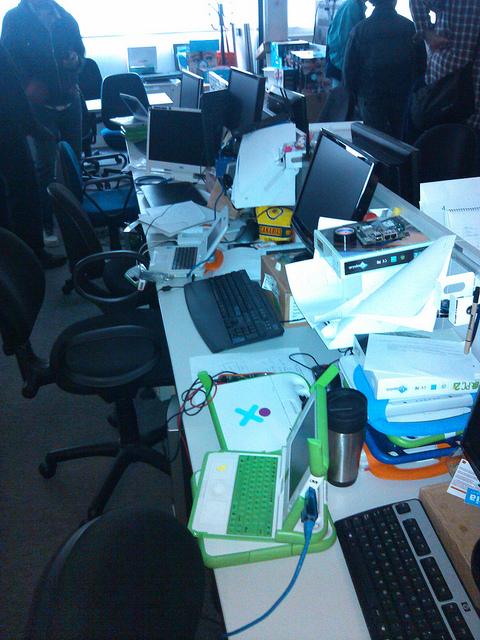Does this look like someone's house?
Concise answer only. No. Are any of the laptops open?
Answer briefly. Yes. Are there any books on the desk?
Give a very brief answer. Yes. 